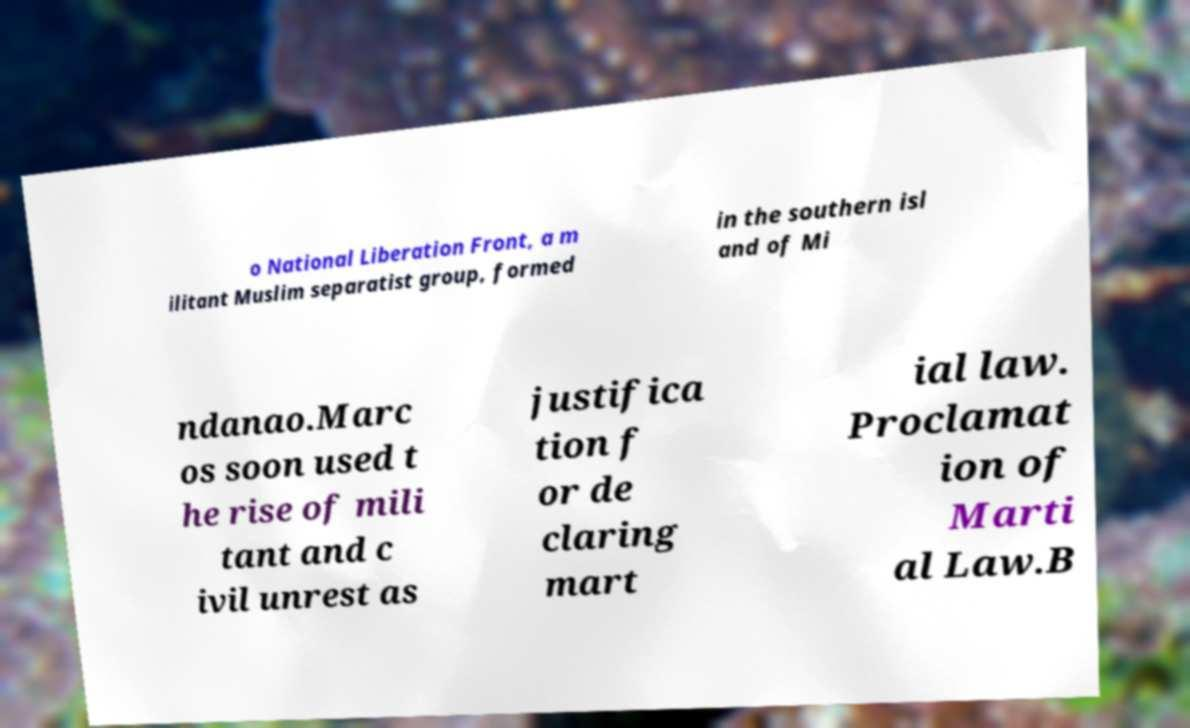For documentation purposes, I need the text within this image transcribed. Could you provide that? o National Liberation Front, a m ilitant Muslim separatist group, formed in the southern isl and of Mi ndanao.Marc os soon used t he rise of mili tant and c ivil unrest as justifica tion f or de claring mart ial law. Proclamat ion of Marti al Law.B 